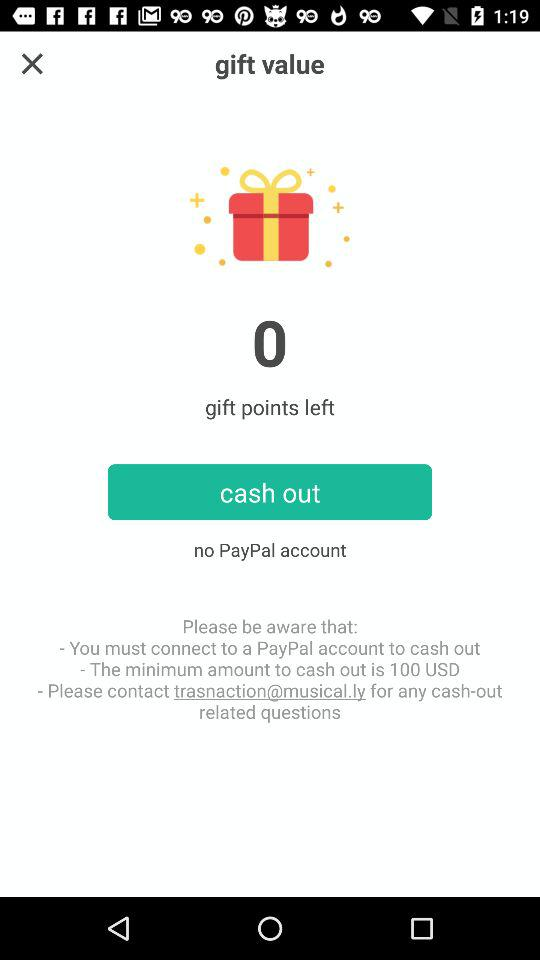How many gift points are left? There are 0 left gift points. 